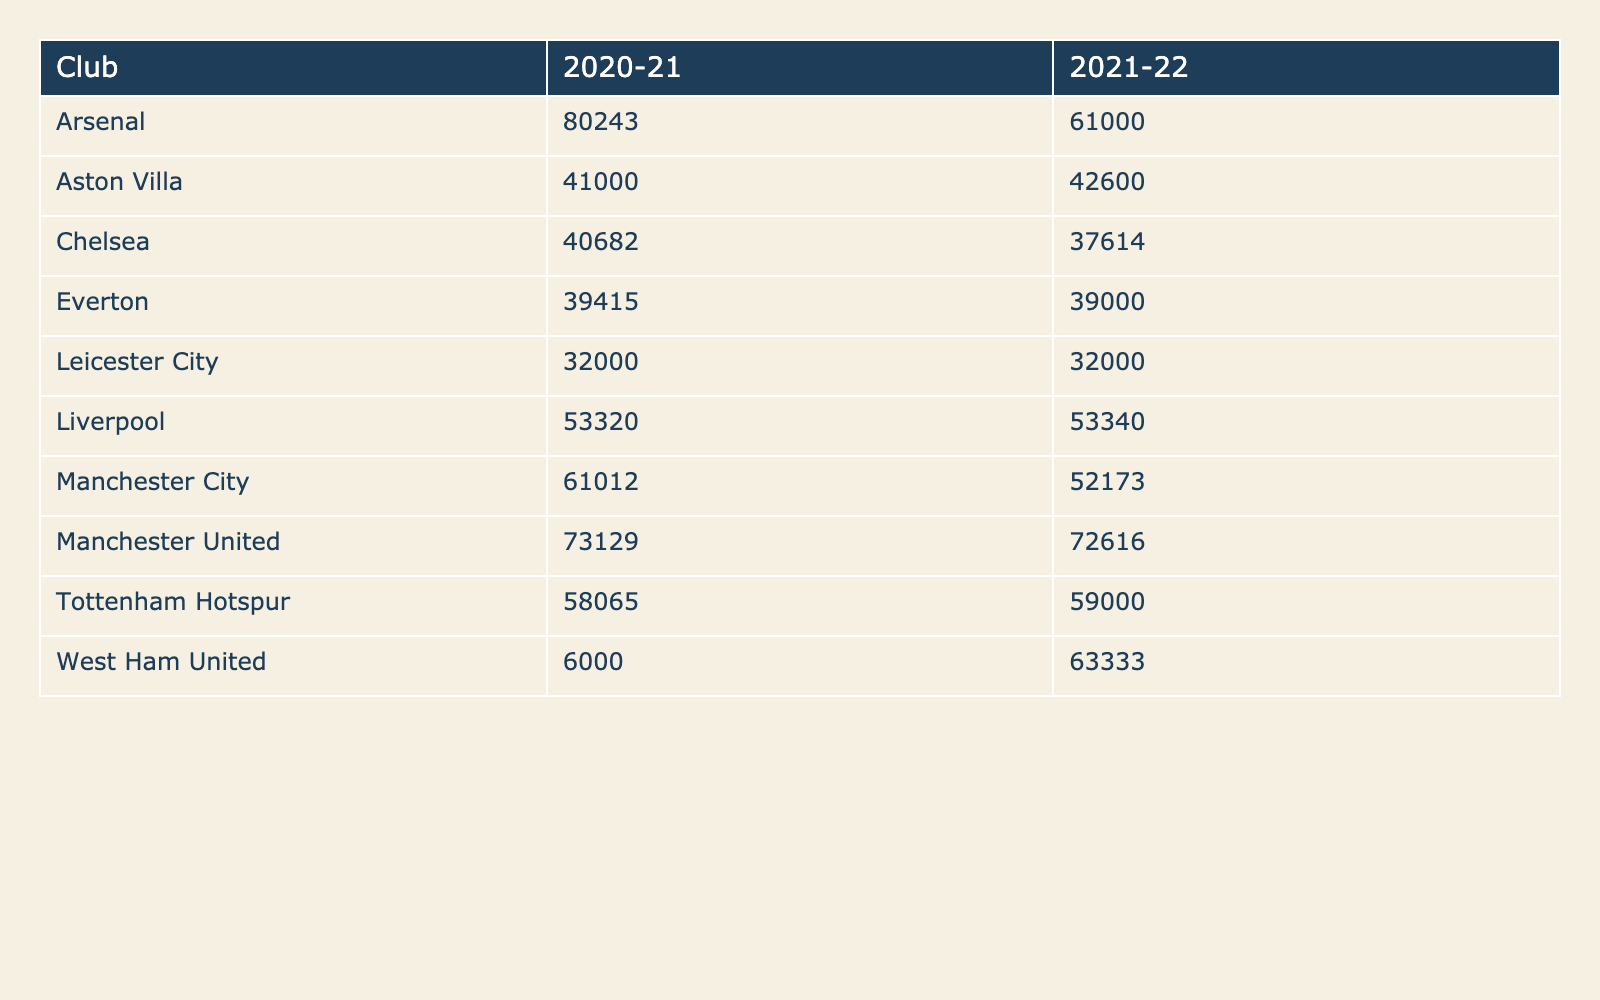What is the average attendance for Arsenal in the 2020-21 season? The table shows that Arsenal's average attendance in the 2020-21 season is explicitly listed as 80243.
Answer: 80243 Which club had the lowest average attendance in the 2021-22 season? By examining the 2021-22 season data, Leicester City is noted with an average attendance of 32000, which is the lowest among all clubs.
Answer: Leicester City What is the difference in average attendance for Manchester United between the two seasons? The average attendance for Manchester United in the 2020-21 season is 73129, while in 2021-22 it is 72616. The difference is calculated as 73129 - 72616 = 513.
Answer: 513 Did Liverpool have a higher average attendance in the 2021-22 season compared to the 2020-21 season? From the table data, Liverpool's average attendance in 2020-21 was 53320, and in 2021-22 it was 53340. Since 53340 is greater than 53320, the answer is yes.
Answer: Yes What is the total average attendance for Chelsea over both seasons? The average attendance for Chelsea is 40682 in 2020-21 and 37614 in 2021-22. The total is calculated by adding these two values: 40682 + 37614 = 78296.
Answer: 78296 Which club had the highest average attendance in the 2021-22 season, and what was that attendance? Referring to the table for the 2021-22 season, Arsenal has the highest average attendance of 61000.
Answer: Arsenal, 61000 Is the average attendance for Tottenham Hotspur higher in 2021-22 than for Aston Villa in the same season? Tottenham Hotspur's average attendance in 2021-22 is 59000, while Aston Villa's is 42600. Since 59000 is greater, the answer is yes.
Answer: Yes How does the average attendance for West Ham United change from 2020-21 to 2021-22? In the 2020-21 season, West Ham United had an average attendance of 6000, and in 2021-22, it increased to 63333. The change is significant, from 6000 to 63333.
Answer: Increased What is the average attendance for all clubs in the 2020-21 season? By summing the average attendance for all clubs in that season (73129 + 53320 + 40682 + 80243 + 58065 + 61012 + 32000 + 6000 + 41000 + 39415), the total equals  3,780,087, and dividing by the 10 clubs gives an average of 378008.7 / 10 = 37800.87.
Answer: 37800.87 